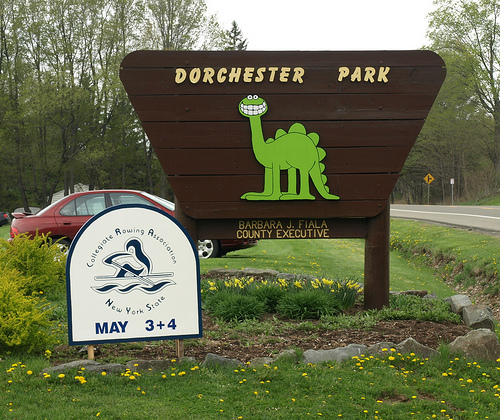<image>
Can you confirm if the dinosaur is on the sign? Yes. Looking at the image, I can see the dinosaur is positioned on top of the sign, with the sign providing support. Where is the dinosaur in relation to the car? Is it in front of the car? Yes. The dinosaur is positioned in front of the car, appearing closer to the camera viewpoint. Where is the sign in relation to the car? Is it in front of the car? Yes. The sign is positioned in front of the car, appearing closer to the camera viewpoint. 